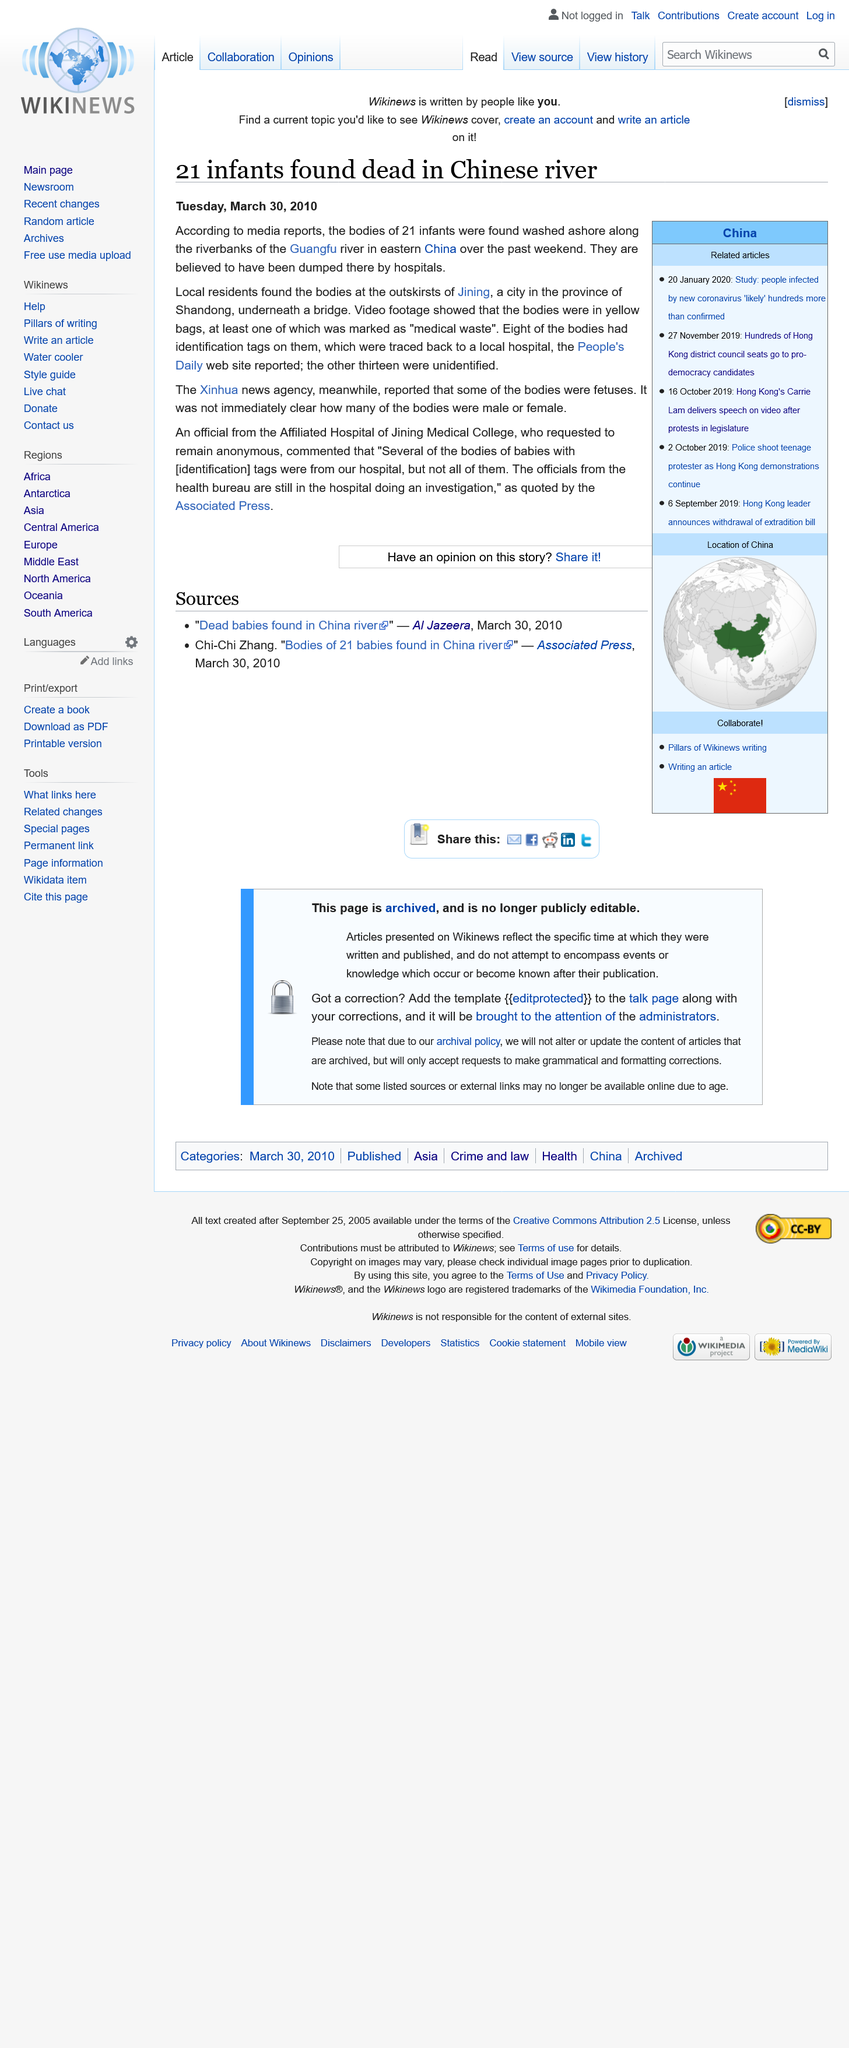Indicate a few pertinent items in this graphic. A total of 21 infants' bodies were discovered in the riverbanks. The majority of the bodies were unidentified, with 13 of them being unidentifiable. The bodies were found in the riverbanks of the Guangfu river in eastern China. 